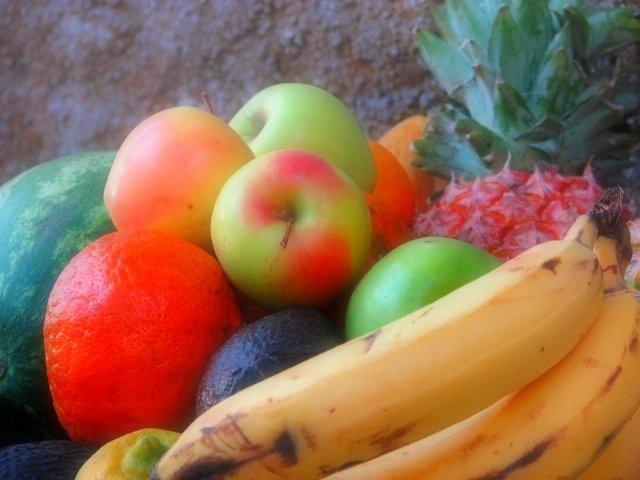How many oranges are there?
Give a very brief answer. 2. How many apples can be seen?
Give a very brief answer. 4. How many bananas can you see?
Give a very brief answer. 2. 